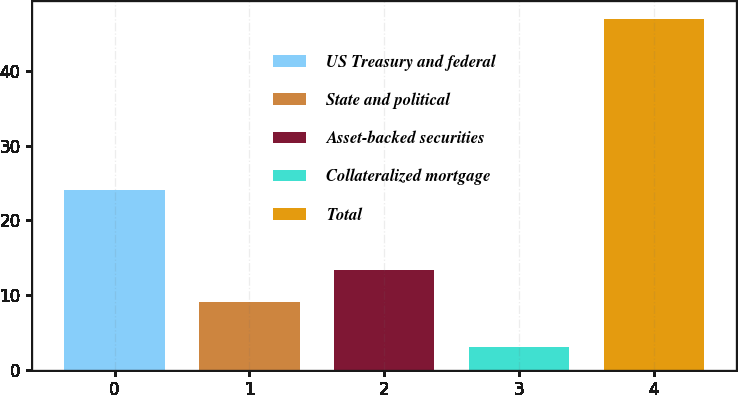Convert chart. <chart><loc_0><loc_0><loc_500><loc_500><bar_chart><fcel>US Treasury and federal<fcel>State and political<fcel>Asset-backed securities<fcel>Collateralized mortgage<fcel>Total<nl><fcel>24<fcel>9<fcel>13.4<fcel>3<fcel>47<nl></chart> 